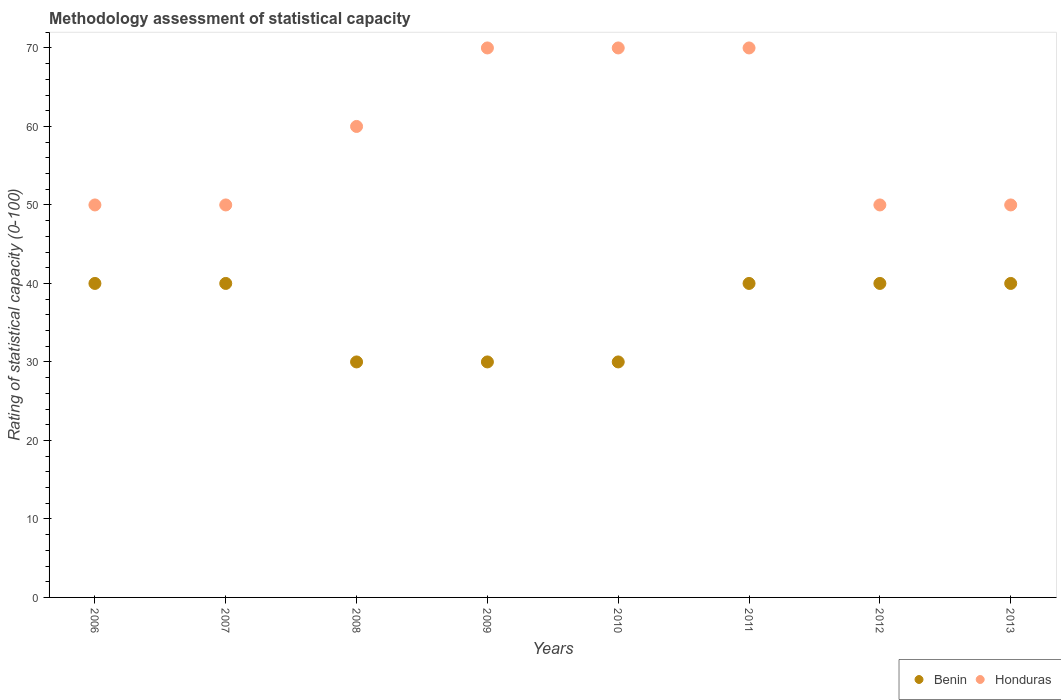What is the rating of statistical capacity in Honduras in 2008?
Keep it short and to the point. 60. Across all years, what is the maximum rating of statistical capacity in Benin?
Give a very brief answer. 40. Across all years, what is the minimum rating of statistical capacity in Benin?
Provide a succinct answer. 30. In which year was the rating of statistical capacity in Honduras minimum?
Ensure brevity in your answer.  2006. What is the total rating of statistical capacity in Honduras in the graph?
Your response must be concise. 470. What is the difference between the rating of statistical capacity in Honduras in 2010 and that in 2013?
Keep it short and to the point. 20. What is the difference between the rating of statistical capacity in Benin in 2006 and the rating of statistical capacity in Honduras in 2008?
Your response must be concise. -20. What is the average rating of statistical capacity in Honduras per year?
Make the answer very short. 58.75. In the year 2010, what is the difference between the rating of statistical capacity in Honduras and rating of statistical capacity in Benin?
Provide a succinct answer. 40. In how many years, is the rating of statistical capacity in Benin greater than 28?
Keep it short and to the point. 8. What is the ratio of the rating of statistical capacity in Benin in 2006 to that in 2013?
Your answer should be very brief. 1. Is the rating of statistical capacity in Benin in 2010 less than that in 2013?
Provide a short and direct response. Yes. What is the difference between the highest and the lowest rating of statistical capacity in Benin?
Provide a short and direct response. 10. Is the rating of statistical capacity in Benin strictly less than the rating of statistical capacity in Honduras over the years?
Offer a terse response. Yes. How many dotlines are there?
Your answer should be compact. 2. What is the difference between two consecutive major ticks on the Y-axis?
Keep it short and to the point. 10. Does the graph contain any zero values?
Give a very brief answer. No. Where does the legend appear in the graph?
Provide a succinct answer. Bottom right. How many legend labels are there?
Keep it short and to the point. 2. What is the title of the graph?
Make the answer very short. Methodology assessment of statistical capacity. Does "Central African Republic" appear as one of the legend labels in the graph?
Provide a short and direct response. No. What is the label or title of the X-axis?
Your answer should be compact. Years. What is the label or title of the Y-axis?
Provide a short and direct response. Rating of statistical capacity (0-100). What is the Rating of statistical capacity (0-100) of Honduras in 2007?
Your response must be concise. 50. What is the Rating of statistical capacity (0-100) in Honduras in 2008?
Your answer should be very brief. 60. What is the Rating of statistical capacity (0-100) in Benin in 2009?
Ensure brevity in your answer.  30. What is the Rating of statistical capacity (0-100) of Honduras in 2009?
Ensure brevity in your answer.  70. What is the Rating of statistical capacity (0-100) in Benin in 2010?
Give a very brief answer. 30. What is the Rating of statistical capacity (0-100) in Honduras in 2011?
Your answer should be compact. 70. What is the Rating of statistical capacity (0-100) of Benin in 2012?
Offer a very short reply. 40. What is the Rating of statistical capacity (0-100) in Honduras in 2012?
Your answer should be very brief. 50. Across all years, what is the maximum Rating of statistical capacity (0-100) in Benin?
Ensure brevity in your answer.  40. Across all years, what is the maximum Rating of statistical capacity (0-100) in Honduras?
Give a very brief answer. 70. Across all years, what is the minimum Rating of statistical capacity (0-100) in Honduras?
Offer a very short reply. 50. What is the total Rating of statistical capacity (0-100) in Benin in the graph?
Provide a short and direct response. 290. What is the total Rating of statistical capacity (0-100) of Honduras in the graph?
Provide a short and direct response. 470. What is the difference between the Rating of statistical capacity (0-100) of Benin in 2006 and that in 2007?
Provide a succinct answer. 0. What is the difference between the Rating of statistical capacity (0-100) in Honduras in 2006 and that in 2007?
Keep it short and to the point. 0. What is the difference between the Rating of statistical capacity (0-100) of Honduras in 2006 and that in 2008?
Your answer should be very brief. -10. What is the difference between the Rating of statistical capacity (0-100) of Honduras in 2006 and that in 2009?
Your answer should be compact. -20. What is the difference between the Rating of statistical capacity (0-100) of Honduras in 2006 and that in 2010?
Make the answer very short. -20. What is the difference between the Rating of statistical capacity (0-100) in Benin in 2006 and that in 2011?
Provide a succinct answer. 0. What is the difference between the Rating of statistical capacity (0-100) in Honduras in 2006 and that in 2011?
Your answer should be very brief. -20. What is the difference between the Rating of statistical capacity (0-100) in Benin in 2007 and that in 2008?
Provide a short and direct response. 10. What is the difference between the Rating of statistical capacity (0-100) in Honduras in 2007 and that in 2008?
Offer a very short reply. -10. What is the difference between the Rating of statistical capacity (0-100) of Benin in 2007 and that in 2009?
Your answer should be compact. 10. What is the difference between the Rating of statistical capacity (0-100) of Honduras in 2007 and that in 2009?
Your answer should be very brief. -20. What is the difference between the Rating of statistical capacity (0-100) of Honduras in 2007 and that in 2010?
Your answer should be compact. -20. What is the difference between the Rating of statistical capacity (0-100) in Honduras in 2007 and that in 2011?
Give a very brief answer. -20. What is the difference between the Rating of statistical capacity (0-100) of Benin in 2007 and that in 2012?
Give a very brief answer. 0. What is the difference between the Rating of statistical capacity (0-100) in Benin in 2007 and that in 2013?
Your answer should be compact. 0. What is the difference between the Rating of statistical capacity (0-100) in Benin in 2008 and that in 2009?
Provide a short and direct response. 0. What is the difference between the Rating of statistical capacity (0-100) of Honduras in 2008 and that in 2010?
Ensure brevity in your answer.  -10. What is the difference between the Rating of statistical capacity (0-100) of Benin in 2008 and that in 2011?
Keep it short and to the point. -10. What is the difference between the Rating of statistical capacity (0-100) in Honduras in 2008 and that in 2011?
Offer a very short reply. -10. What is the difference between the Rating of statistical capacity (0-100) in Benin in 2008 and that in 2013?
Offer a very short reply. -10. What is the difference between the Rating of statistical capacity (0-100) of Honduras in 2008 and that in 2013?
Your response must be concise. 10. What is the difference between the Rating of statistical capacity (0-100) in Benin in 2009 and that in 2010?
Offer a very short reply. 0. What is the difference between the Rating of statistical capacity (0-100) in Benin in 2009 and that in 2011?
Make the answer very short. -10. What is the difference between the Rating of statistical capacity (0-100) in Honduras in 2009 and that in 2011?
Give a very brief answer. 0. What is the difference between the Rating of statistical capacity (0-100) of Honduras in 2009 and that in 2012?
Offer a very short reply. 20. What is the difference between the Rating of statistical capacity (0-100) of Benin in 2010 and that in 2011?
Provide a short and direct response. -10. What is the difference between the Rating of statistical capacity (0-100) of Benin in 2010 and that in 2012?
Ensure brevity in your answer.  -10. What is the difference between the Rating of statistical capacity (0-100) in Benin in 2010 and that in 2013?
Keep it short and to the point. -10. What is the difference between the Rating of statistical capacity (0-100) in Honduras in 2011 and that in 2012?
Your answer should be compact. 20. What is the difference between the Rating of statistical capacity (0-100) of Honduras in 2011 and that in 2013?
Give a very brief answer. 20. What is the difference between the Rating of statistical capacity (0-100) of Honduras in 2012 and that in 2013?
Ensure brevity in your answer.  0. What is the difference between the Rating of statistical capacity (0-100) of Benin in 2006 and the Rating of statistical capacity (0-100) of Honduras in 2007?
Make the answer very short. -10. What is the difference between the Rating of statistical capacity (0-100) in Benin in 2006 and the Rating of statistical capacity (0-100) in Honduras in 2011?
Ensure brevity in your answer.  -30. What is the difference between the Rating of statistical capacity (0-100) of Benin in 2006 and the Rating of statistical capacity (0-100) of Honduras in 2012?
Ensure brevity in your answer.  -10. What is the difference between the Rating of statistical capacity (0-100) in Benin in 2006 and the Rating of statistical capacity (0-100) in Honduras in 2013?
Make the answer very short. -10. What is the difference between the Rating of statistical capacity (0-100) in Benin in 2007 and the Rating of statistical capacity (0-100) in Honduras in 2010?
Offer a very short reply. -30. What is the difference between the Rating of statistical capacity (0-100) of Benin in 2007 and the Rating of statistical capacity (0-100) of Honduras in 2011?
Provide a short and direct response. -30. What is the difference between the Rating of statistical capacity (0-100) in Benin in 2007 and the Rating of statistical capacity (0-100) in Honduras in 2012?
Your answer should be compact. -10. What is the difference between the Rating of statistical capacity (0-100) of Benin in 2008 and the Rating of statistical capacity (0-100) of Honduras in 2010?
Provide a succinct answer. -40. What is the difference between the Rating of statistical capacity (0-100) in Benin in 2008 and the Rating of statistical capacity (0-100) in Honduras in 2011?
Make the answer very short. -40. What is the difference between the Rating of statistical capacity (0-100) of Benin in 2008 and the Rating of statistical capacity (0-100) of Honduras in 2012?
Provide a succinct answer. -20. What is the difference between the Rating of statistical capacity (0-100) of Benin in 2009 and the Rating of statistical capacity (0-100) of Honduras in 2013?
Your answer should be very brief. -20. What is the difference between the Rating of statistical capacity (0-100) in Benin in 2010 and the Rating of statistical capacity (0-100) in Honduras in 2011?
Offer a terse response. -40. What is the difference between the Rating of statistical capacity (0-100) of Benin in 2010 and the Rating of statistical capacity (0-100) of Honduras in 2013?
Offer a very short reply. -20. What is the average Rating of statistical capacity (0-100) of Benin per year?
Offer a terse response. 36.25. What is the average Rating of statistical capacity (0-100) in Honduras per year?
Give a very brief answer. 58.75. In the year 2006, what is the difference between the Rating of statistical capacity (0-100) of Benin and Rating of statistical capacity (0-100) of Honduras?
Give a very brief answer. -10. In the year 2009, what is the difference between the Rating of statistical capacity (0-100) of Benin and Rating of statistical capacity (0-100) of Honduras?
Give a very brief answer. -40. In the year 2011, what is the difference between the Rating of statistical capacity (0-100) in Benin and Rating of statistical capacity (0-100) in Honduras?
Your response must be concise. -30. In the year 2013, what is the difference between the Rating of statistical capacity (0-100) of Benin and Rating of statistical capacity (0-100) of Honduras?
Offer a very short reply. -10. What is the ratio of the Rating of statistical capacity (0-100) in Honduras in 2006 to that in 2007?
Your answer should be very brief. 1. What is the ratio of the Rating of statistical capacity (0-100) in Benin in 2006 to that in 2008?
Give a very brief answer. 1.33. What is the ratio of the Rating of statistical capacity (0-100) in Honduras in 2006 to that in 2008?
Your answer should be very brief. 0.83. What is the ratio of the Rating of statistical capacity (0-100) of Benin in 2006 to that in 2010?
Your response must be concise. 1.33. What is the ratio of the Rating of statistical capacity (0-100) in Benin in 2007 to that in 2008?
Offer a terse response. 1.33. What is the ratio of the Rating of statistical capacity (0-100) of Honduras in 2007 to that in 2008?
Make the answer very short. 0.83. What is the ratio of the Rating of statistical capacity (0-100) of Benin in 2007 to that in 2009?
Ensure brevity in your answer.  1.33. What is the ratio of the Rating of statistical capacity (0-100) in Benin in 2007 to that in 2011?
Ensure brevity in your answer.  1. What is the ratio of the Rating of statistical capacity (0-100) of Benin in 2007 to that in 2012?
Keep it short and to the point. 1. What is the ratio of the Rating of statistical capacity (0-100) in Honduras in 2008 to that in 2009?
Your answer should be compact. 0.86. What is the ratio of the Rating of statistical capacity (0-100) of Honduras in 2008 to that in 2010?
Provide a succinct answer. 0.86. What is the ratio of the Rating of statistical capacity (0-100) in Benin in 2008 to that in 2011?
Keep it short and to the point. 0.75. What is the ratio of the Rating of statistical capacity (0-100) of Honduras in 2008 to that in 2011?
Keep it short and to the point. 0.86. What is the ratio of the Rating of statistical capacity (0-100) in Honduras in 2008 to that in 2012?
Offer a very short reply. 1.2. What is the ratio of the Rating of statistical capacity (0-100) in Honduras in 2008 to that in 2013?
Provide a short and direct response. 1.2. What is the ratio of the Rating of statistical capacity (0-100) in Benin in 2009 to that in 2010?
Your answer should be very brief. 1. What is the ratio of the Rating of statistical capacity (0-100) in Benin in 2009 to that in 2011?
Offer a very short reply. 0.75. What is the ratio of the Rating of statistical capacity (0-100) in Benin in 2009 to that in 2012?
Provide a short and direct response. 0.75. What is the ratio of the Rating of statistical capacity (0-100) in Honduras in 2009 to that in 2013?
Your answer should be very brief. 1.4. What is the ratio of the Rating of statistical capacity (0-100) of Benin in 2010 to that in 2012?
Your answer should be compact. 0.75. What is the ratio of the Rating of statistical capacity (0-100) of Honduras in 2010 to that in 2012?
Your answer should be compact. 1.4. What is the ratio of the Rating of statistical capacity (0-100) in Benin in 2010 to that in 2013?
Your answer should be very brief. 0.75. What is the ratio of the Rating of statistical capacity (0-100) in Honduras in 2010 to that in 2013?
Give a very brief answer. 1.4. What is the ratio of the Rating of statistical capacity (0-100) in Benin in 2011 to that in 2012?
Provide a short and direct response. 1. What is the difference between the highest and the second highest Rating of statistical capacity (0-100) in Benin?
Offer a very short reply. 0. What is the difference between the highest and the second highest Rating of statistical capacity (0-100) in Honduras?
Your answer should be very brief. 0. What is the difference between the highest and the lowest Rating of statistical capacity (0-100) in Honduras?
Provide a succinct answer. 20. 